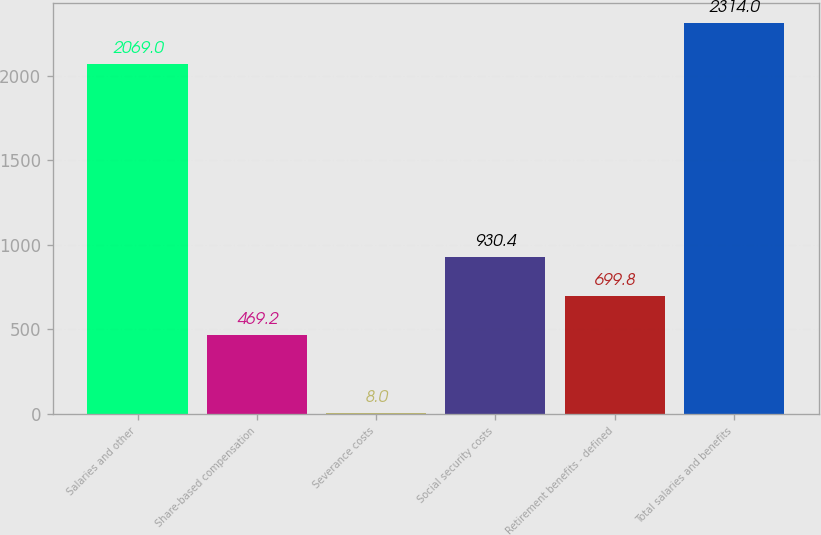Convert chart to OTSL. <chart><loc_0><loc_0><loc_500><loc_500><bar_chart><fcel>Salaries and other<fcel>Share-based compensation<fcel>Severance costs<fcel>Social security costs<fcel>Retirement benefits - defined<fcel>Total salaries and benefits<nl><fcel>2069<fcel>469.2<fcel>8<fcel>930.4<fcel>699.8<fcel>2314<nl></chart> 